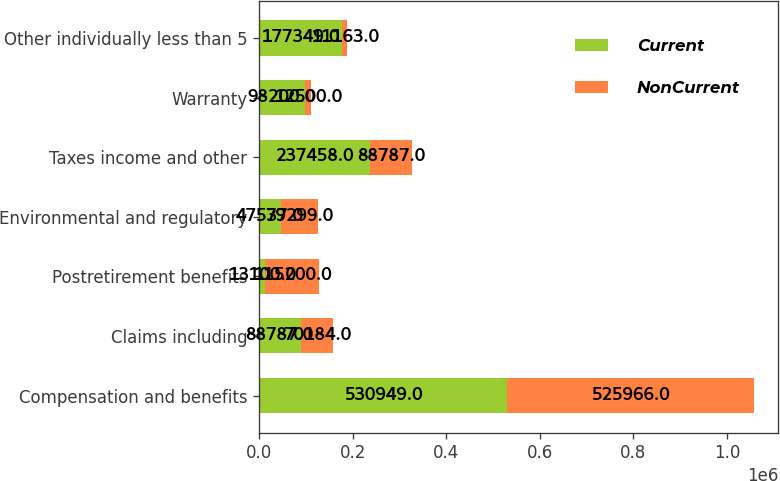Convert chart. <chart><loc_0><loc_0><loc_500><loc_500><stacked_bar_chart><ecel><fcel>Compensation and benefits<fcel>Claims including<fcel>Postretirement benefits<fcel>Environmental and regulatory<fcel>Taxes income and other<fcel>Warranty<fcel>Other individually less than 5<nl><fcel>Current<fcel>530949<fcel>88787<fcel>13100<fcel>47537<fcel>237458<fcel>98200<fcel>177349<nl><fcel>NonCurrent<fcel>525966<fcel>70184<fcel>115200<fcel>79299<fcel>88787<fcel>12500<fcel>11163<nl></chart> 